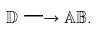<formula> <loc_0><loc_0><loc_500><loc_500>\mathbb { D } \longrightarrow \mathbb { A B } .</formula> 